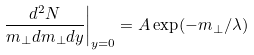Convert formula to latex. <formula><loc_0><loc_0><loc_500><loc_500>\left . \frac { d ^ { 2 } N } { m _ { \perp } d m _ { \perp } d y } \right | _ { y = 0 } = A \exp ( - m _ { \perp } / \lambda )</formula> 